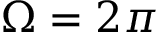<formula> <loc_0><loc_0><loc_500><loc_500>\Omega = 2 \pi</formula> 